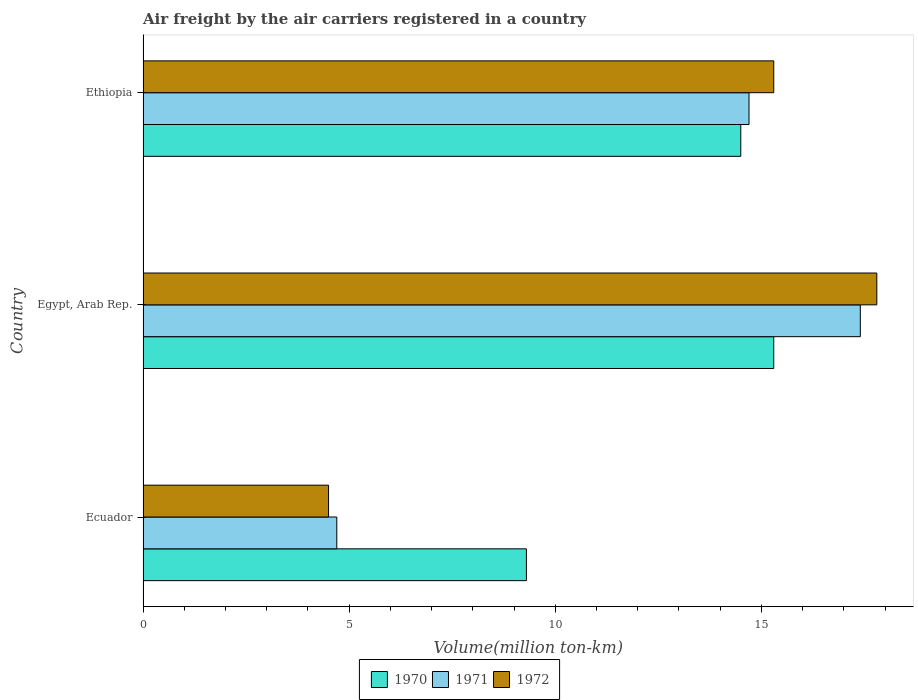How many groups of bars are there?
Keep it short and to the point. 3. What is the label of the 2nd group of bars from the top?
Provide a succinct answer. Egypt, Arab Rep. In how many cases, is the number of bars for a given country not equal to the number of legend labels?
Offer a terse response. 0. What is the volume of the air carriers in 1971 in Egypt, Arab Rep.?
Keep it short and to the point. 17.4. Across all countries, what is the maximum volume of the air carriers in 1972?
Keep it short and to the point. 17.8. Across all countries, what is the minimum volume of the air carriers in 1970?
Give a very brief answer. 9.3. In which country was the volume of the air carriers in 1971 maximum?
Your answer should be very brief. Egypt, Arab Rep. In which country was the volume of the air carriers in 1971 minimum?
Keep it short and to the point. Ecuador. What is the total volume of the air carriers in 1972 in the graph?
Your answer should be very brief. 37.6. What is the difference between the volume of the air carriers in 1972 in Ecuador and that in Egypt, Arab Rep.?
Your response must be concise. -13.3. What is the difference between the volume of the air carriers in 1972 in Ethiopia and the volume of the air carriers in 1971 in Egypt, Arab Rep.?
Provide a succinct answer. -2.1. What is the average volume of the air carriers in 1971 per country?
Provide a succinct answer. 12.27. What is the difference between the volume of the air carriers in 1971 and volume of the air carriers in 1972 in Ecuador?
Your response must be concise. 0.2. What is the ratio of the volume of the air carriers in 1972 in Ecuador to that in Egypt, Arab Rep.?
Provide a succinct answer. 0.25. Is the difference between the volume of the air carriers in 1971 in Egypt, Arab Rep. and Ethiopia greater than the difference between the volume of the air carriers in 1972 in Egypt, Arab Rep. and Ethiopia?
Keep it short and to the point. Yes. What is the difference between the highest and the second highest volume of the air carriers in 1970?
Offer a terse response. 0.8. In how many countries, is the volume of the air carriers in 1971 greater than the average volume of the air carriers in 1971 taken over all countries?
Provide a succinct answer. 2. How many countries are there in the graph?
Offer a terse response. 3. What is the difference between two consecutive major ticks on the X-axis?
Your answer should be compact. 5. Are the values on the major ticks of X-axis written in scientific E-notation?
Your answer should be compact. No. Does the graph contain any zero values?
Your response must be concise. No. How many legend labels are there?
Offer a terse response. 3. How are the legend labels stacked?
Your response must be concise. Horizontal. What is the title of the graph?
Offer a terse response. Air freight by the air carriers registered in a country. Does "1978" appear as one of the legend labels in the graph?
Provide a succinct answer. No. What is the label or title of the X-axis?
Your response must be concise. Volume(million ton-km). What is the label or title of the Y-axis?
Ensure brevity in your answer.  Country. What is the Volume(million ton-km) in 1970 in Ecuador?
Your answer should be very brief. 9.3. What is the Volume(million ton-km) of 1971 in Ecuador?
Your response must be concise. 4.7. What is the Volume(million ton-km) in 1970 in Egypt, Arab Rep.?
Make the answer very short. 15.3. What is the Volume(million ton-km) in 1971 in Egypt, Arab Rep.?
Your response must be concise. 17.4. What is the Volume(million ton-km) of 1972 in Egypt, Arab Rep.?
Your response must be concise. 17.8. What is the Volume(million ton-km) of 1971 in Ethiopia?
Make the answer very short. 14.7. What is the Volume(million ton-km) of 1972 in Ethiopia?
Give a very brief answer. 15.3. Across all countries, what is the maximum Volume(million ton-km) in 1970?
Your answer should be compact. 15.3. Across all countries, what is the maximum Volume(million ton-km) of 1971?
Provide a short and direct response. 17.4. Across all countries, what is the maximum Volume(million ton-km) in 1972?
Provide a succinct answer. 17.8. Across all countries, what is the minimum Volume(million ton-km) of 1970?
Make the answer very short. 9.3. Across all countries, what is the minimum Volume(million ton-km) in 1971?
Offer a very short reply. 4.7. Across all countries, what is the minimum Volume(million ton-km) in 1972?
Your answer should be very brief. 4.5. What is the total Volume(million ton-km) of 1970 in the graph?
Offer a terse response. 39.1. What is the total Volume(million ton-km) of 1971 in the graph?
Provide a short and direct response. 36.8. What is the total Volume(million ton-km) of 1972 in the graph?
Provide a succinct answer. 37.6. What is the difference between the Volume(million ton-km) in 1971 in Ecuador and that in Egypt, Arab Rep.?
Offer a very short reply. -12.7. What is the difference between the Volume(million ton-km) of 1970 in Ecuador and that in Ethiopia?
Ensure brevity in your answer.  -5.2. What is the difference between the Volume(million ton-km) of 1971 in Ecuador and that in Ethiopia?
Keep it short and to the point. -10. What is the difference between the Volume(million ton-km) of 1972 in Ecuador and that in Ethiopia?
Provide a succinct answer. -10.8. What is the difference between the Volume(million ton-km) of 1971 in Egypt, Arab Rep. and that in Ethiopia?
Provide a short and direct response. 2.7. What is the difference between the Volume(million ton-km) in 1972 in Egypt, Arab Rep. and that in Ethiopia?
Make the answer very short. 2.5. What is the difference between the Volume(million ton-km) in 1970 in Ecuador and the Volume(million ton-km) in 1972 in Ethiopia?
Your answer should be very brief. -6. What is the difference between the Volume(million ton-km) in 1971 in Ecuador and the Volume(million ton-km) in 1972 in Ethiopia?
Your response must be concise. -10.6. What is the difference between the Volume(million ton-km) in 1970 in Egypt, Arab Rep. and the Volume(million ton-km) in 1971 in Ethiopia?
Your response must be concise. 0.6. What is the difference between the Volume(million ton-km) of 1970 in Egypt, Arab Rep. and the Volume(million ton-km) of 1972 in Ethiopia?
Your answer should be very brief. 0. What is the average Volume(million ton-km) in 1970 per country?
Give a very brief answer. 13.03. What is the average Volume(million ton-km) in 1971 per country?
Provide a succinct answer. 12.27. What is the average Volume(million ton-km) in 1972 per country?
Make the answer very short. 12.53. What is the difference between the Volume(million ton-km) of 1970 and Volume(million ton-km) of 1971 in Ecuador?
Offer a terse response. 4.6. What is the difference between the Volume(million ton-km) of 1970 and Volume(million ton-km) of 1971 in Egypt, Arab Rep.?
Provide a succinct answer. -2.1. What is the difference between the Volume(million ton-km) in 1970 and Volume(million ton-km) in 1972 in Egypt, Arab Rep.?
Keep it short and to the point. -2.5. What is the difference between the Volume(million ton-km) in 1970 and Volume(million ton-km) in 1972 in Ethiopia?
Your answer should be compact. -0.8. What is the difference between the Volume(million ton-km) of 1971 and Volume(million ton-km) of 1972 in Ethiopia?
Your answer should be very brief. -0.6. What is the ratio of the Volume(million ton-km) in 1970 in Ecuador to that in Egypt, Arab Rep.?
Your answer should be compact. 0.61. What is the ratio of the Volume(million ton-km) in 1971 in Ecuador to that in Egypt, Arab Rep.?
Offer a very short reply. 0.27. What is the ratio of the Volume(million ton-km) in 1972 in Ecuador to that in Egypt, Arab Rep.?
Your answer should be compact. 0.25. What is the ratio of the Volume(million ton-km) in 1970 in Ecuador to that in Ethiopia?
Offer a very short reply. 0.64. What is the ratio of the Volume(million ton-km) in 1971 in Ecuador to that in Ethiopia?
Offer a terse response. 0.32. What is the ratio of the Volume(million ton-km) in 1972 in Ecuador to that in Ethiopia?
Make the answer very short. 0.29. What is the ratio of the Volume(million ton-km) in 1970 in Egypt, Arab Rep. to that in Ethiopia?
Ensure brevity in your answer.  1.06. What is the ratio of the Volume(million ton-km) in 1971 in Egypt, Arab Rep. to that in Ethiopia?
Your response must be concise. 1.18. What is the ratio of the Volume(million ton-km) of 1972 in Egypt, Arab Rep. to that in Ethiopia?
Offer a terse response. 1.16. What is the difference between the highest and the second highest Volume(million ton-km) of 1970?
Provide a short and direct response. 0.8. 